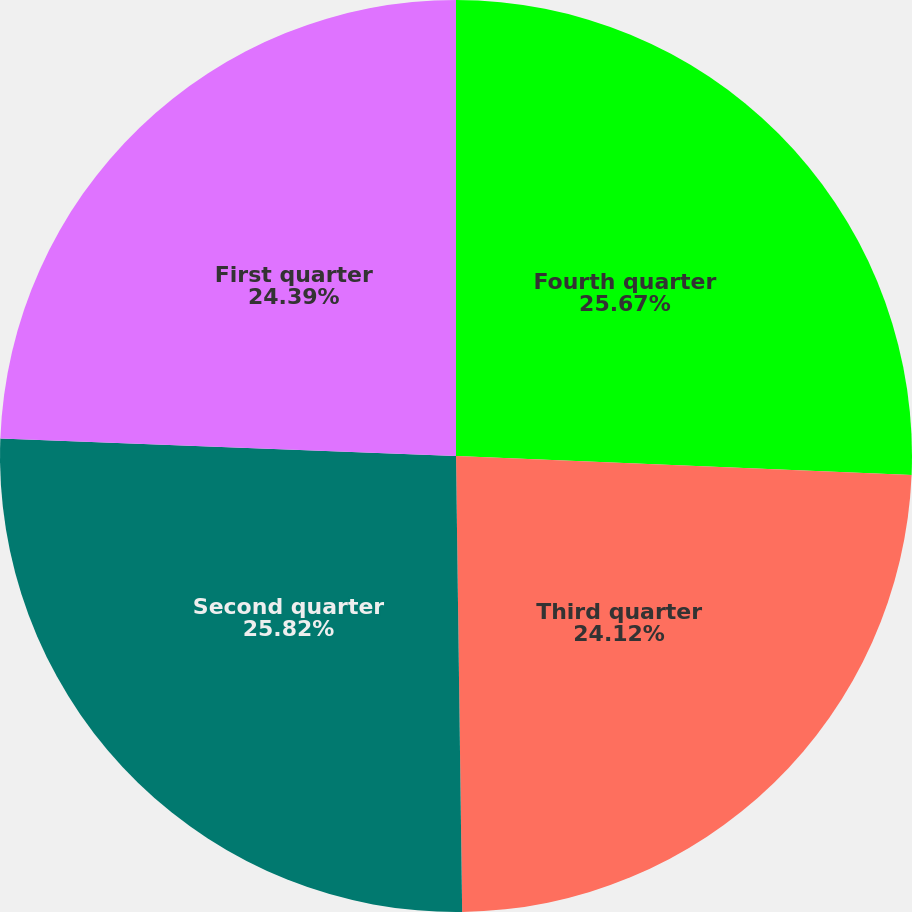Convert chart to OTSL. <chart><loc_0><loc_0><loc_500><loc_500><pie_chart><fcel>Fourth quarter<fcel>Third quarter<fcel>Second quarter<fcel>First quarter<nl><fcel>25.67%<fcel>24.12%<fcel>25.83%<fcel>24.39%<nl></chart> 